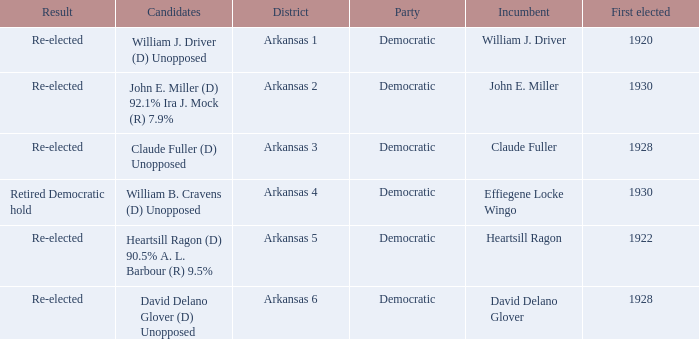What year was incumbent Claude Fuller first elected?  1928.0. 